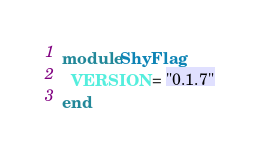Convert code to text. <code><loc_0><loc_0><loc_500><loc_500><_Ruby_>module ShyFlag
  VERSION = "0.1.7"
end
</code> 